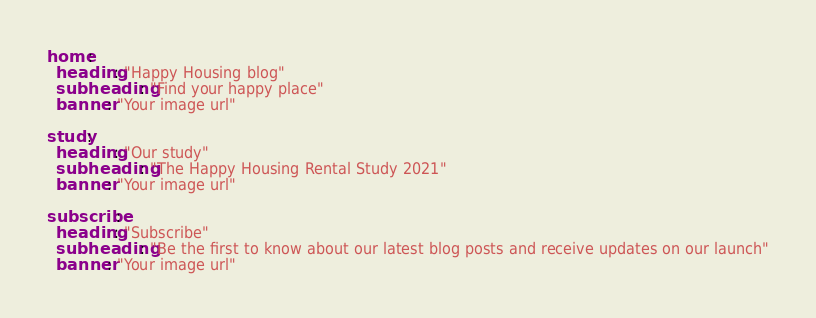Convert code to text. <code><loc_0><loc_0><loc_500><loc_500><_YAML_>home:
  heading: "Happy Housing blog"
  subheading: "Find your happy place"
  banner: "Your image url"

study:
  heading: "Our study"
  subheading: "The Happy Housing Rental Study 2021"
  banner: "Your image url"

subscribe:
  heading: "Subscribe"
  subheading: "Be the first to know about our latest blog posts and receive updates on our launch"
  banner: "Your image url"</code> 